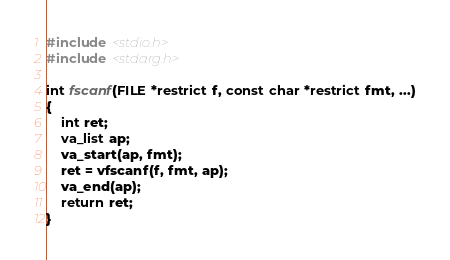Convert code to text. <code><loc_0><loc_0><loc_500><loc_500><_C_>#include <stdio.h>
#include <stdarg.h>

int fscanf(FILE *restrict f, const char *restrict fmt, ...)
{
	int ret;
	va_list ap;
	va_start(ap, fmt);
	ret = vfscanf(f, fmt, ap);
	va_end(ap);
	return ret;
}
</code> 